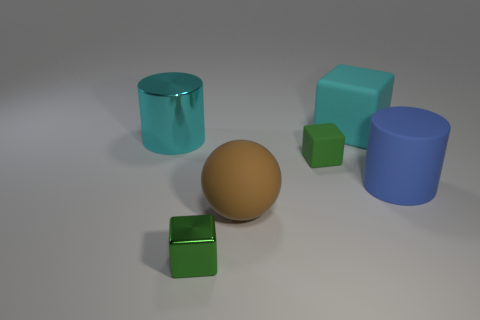Add 3 brown blocks. How many objects exist? 9 Subtract all spheres. How many objects are left? 5 Subtract all small red rubber spheres. Subtract all brown rubber objects. How many objects are left? 5 Add 6 big matte balls. How many big matte balls are left? 7 Add 5 small rubber blocks. How many small rubber blocks exist? 6 Subtract 0 brown cylinders. How many objects are left? 6 